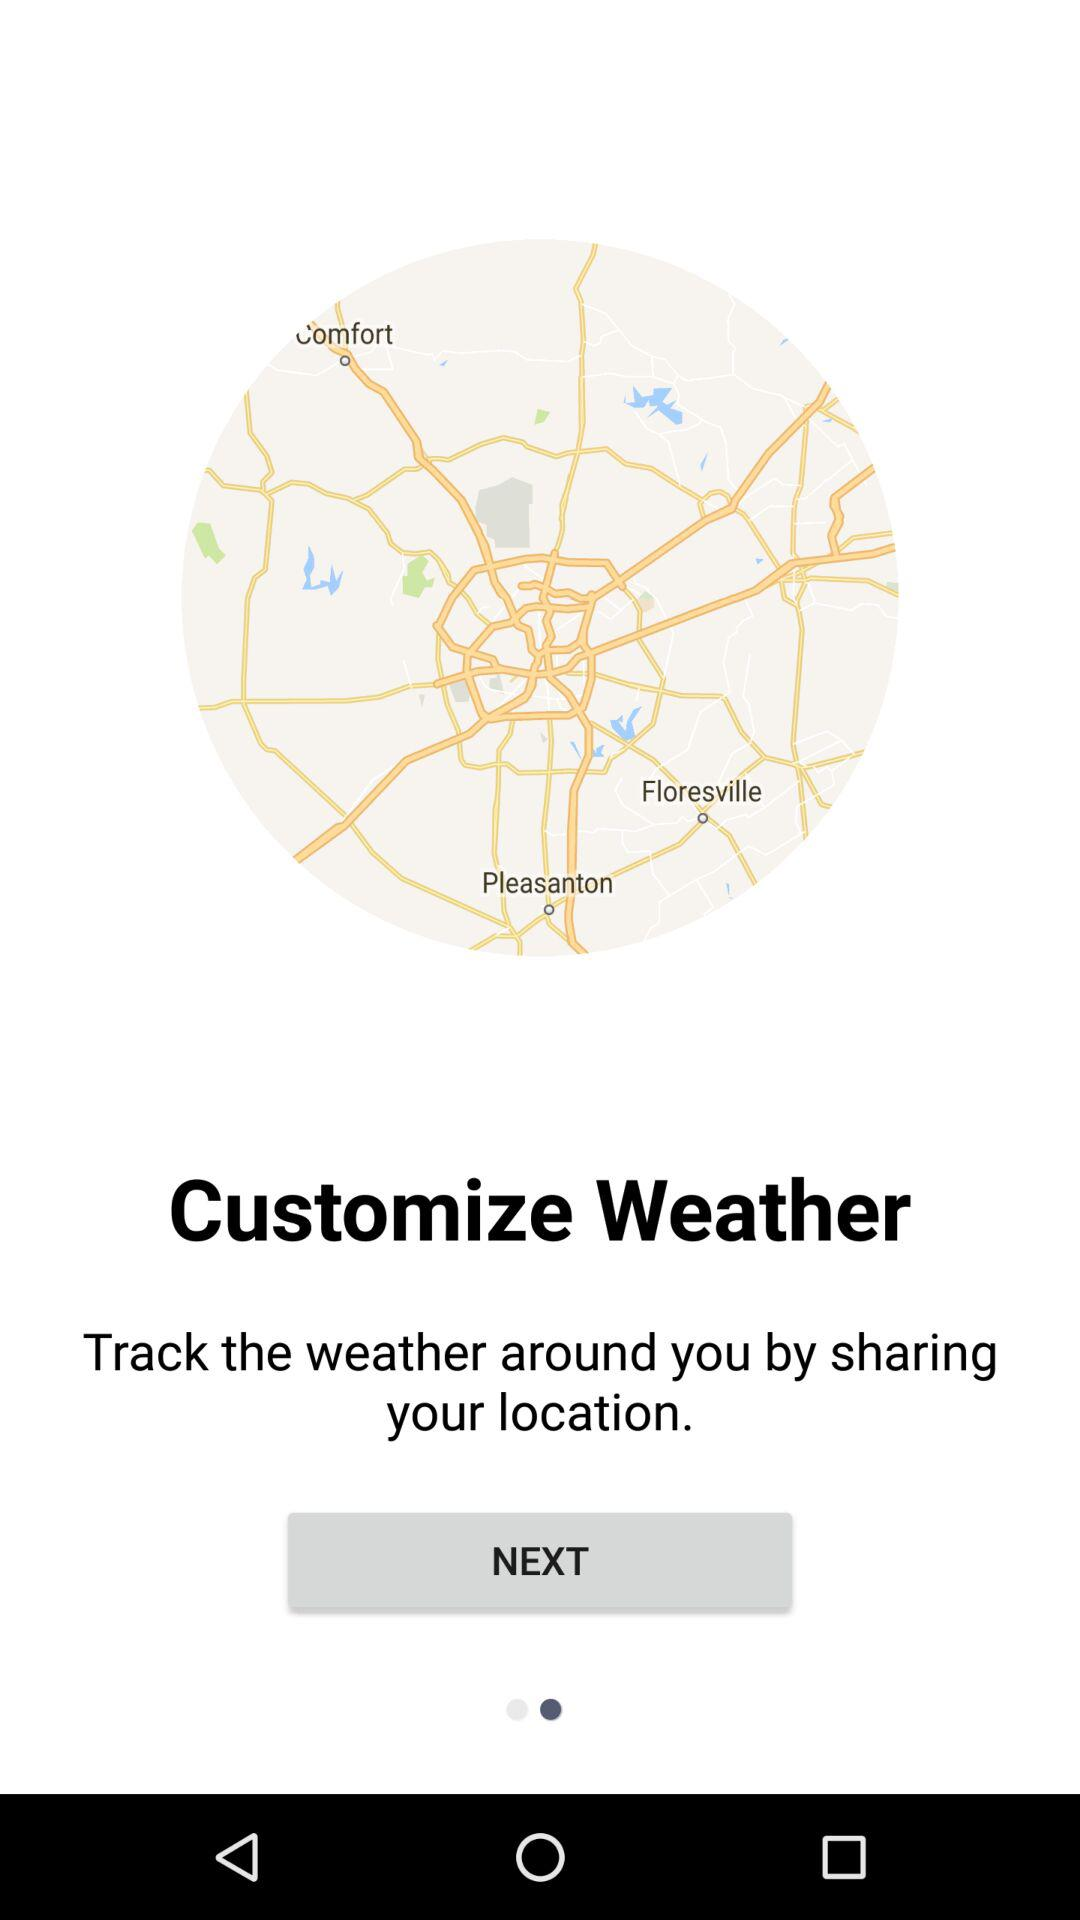What's the application name? The application name is "Customize Weather". 